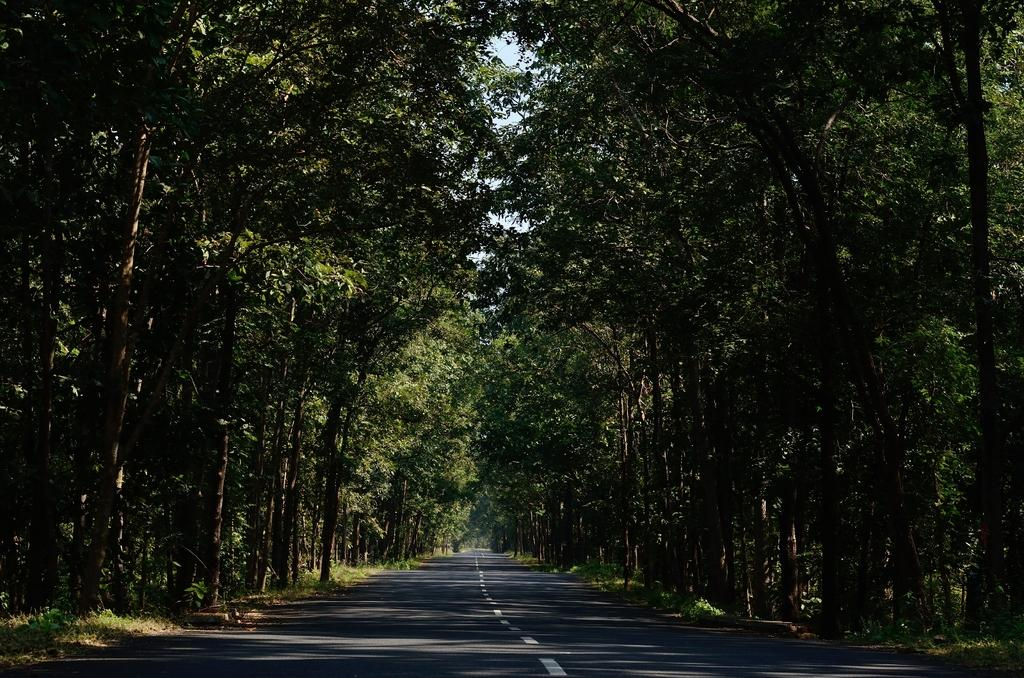What type of vegetation can be seen in the image? There are trees in the image. What is located at the bottom of the image? There is a road at the bottom of the image. What topic is being discussed by the trees in the image? There are no discussions taking place in the image, as trees are inanimate objects and cannot engage in discussions. 